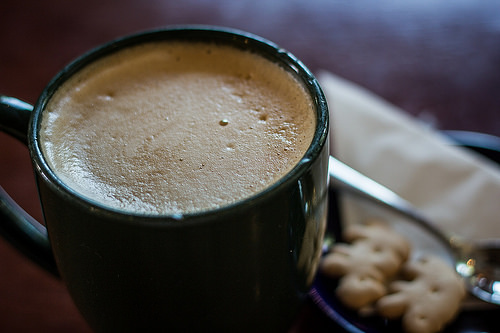<image>
Is there a coffee in the mug? Yes. The coffee is contained within or inside the mug, showing a containment relationship. 